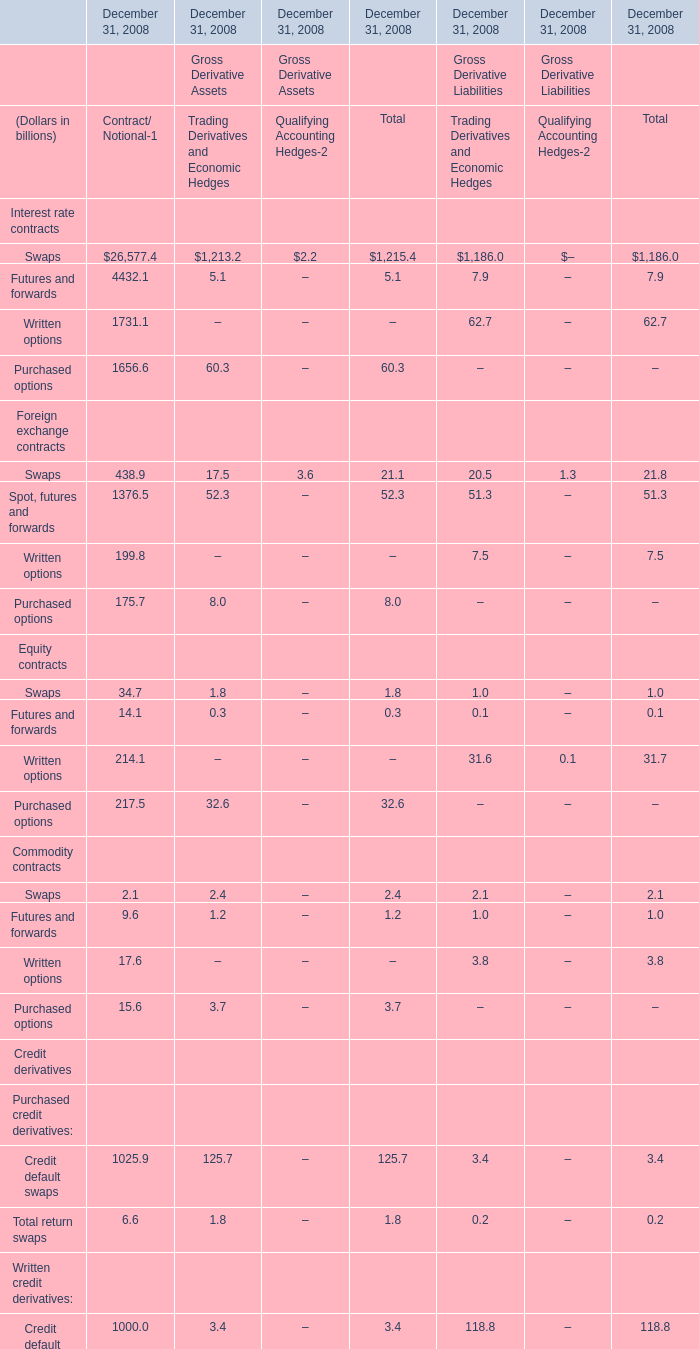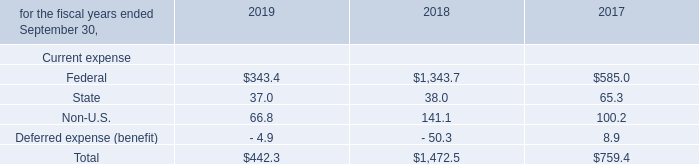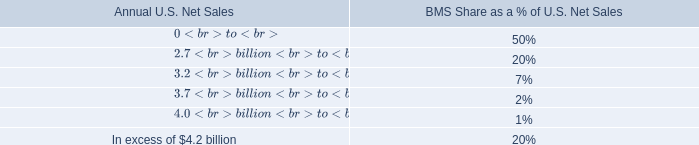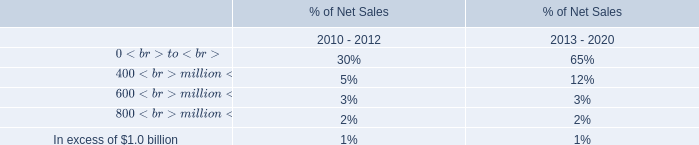What's the total amount of derivative assets/liabilities excluding Less: Cash collateral applied and Less: Legally enforceable master netting agreements in 2008? (in dollars in billions) 
Computations: (((((62.3 + 30.7) + 34.8) + 30.3) + 1438.4) + 1438.4)
Answer: 3034.9. 